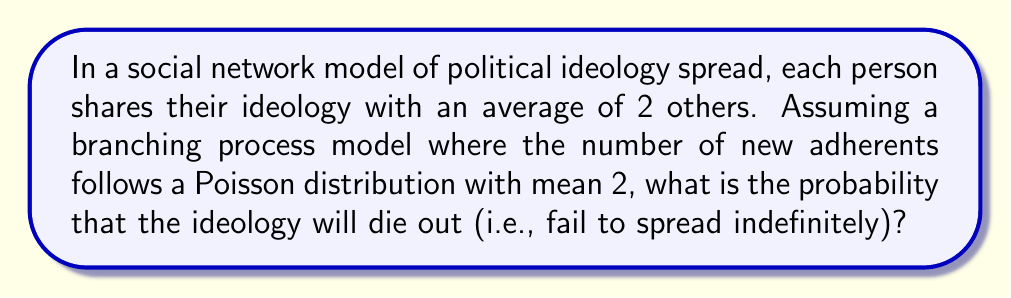Could you help me with this problem? To solve this problem, we'll use the theory of branching processes:

1) In a branching process, the extinction probability $q$ satisfies the equation:
   $q = G(q)$, where $G(s)$ is the probability generating function of the offspring distribution.

2) For a Poisson distribution with mean $\lambda$, the probability generating function is:
   $G(s) = e^{\lambda(s-1)}$

3) In our case, $\lambda = 2$, so:
   $G(s) = e^{2(s-1)}$

4) The extinction probability $q$ satisfies:
   $q = e^{2(q-1)}$

5) This equation can't be solved algebraically, but we can solve it numerically.

6) The non-zero solution to this equation is the extinction probability if it exists and is less than 1.

7) Using numerical methods (e.g., Newton-Raphson), we find:
   $q \approx 0.2032$

8) This means there's about a 20.32% chance the ideology will die out.

9) From a political science perspective, this result suggests that even in a favorable environment for spread (each person influencing two others on average), there's still a significant chance that a political ideology may fail to gain traction in a social network.
Answer: $0.2032$ or $20.32\%$ 